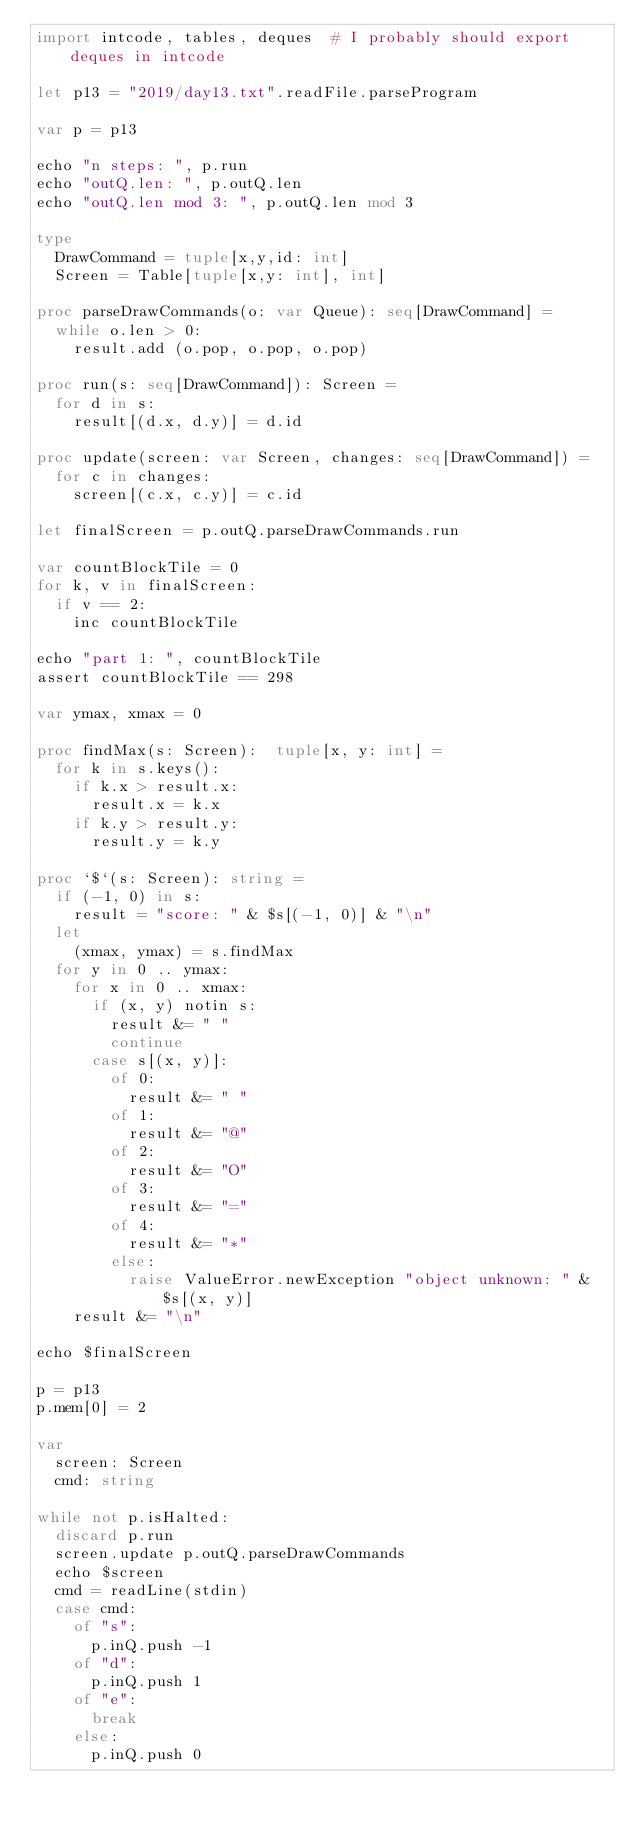<code> <loc_0><loc_0><loc_500><loc_500><_Nim_>import intcode, tables, deques  # I probably should export deques in intcode

let p13 = "2019/day13.txt".readFile.parseProgram

var p = p13

echo "n steps: ", p.run
echo "outQ.len: ", p.outQ.len
echo "outQ.len mod 3: ", p.outQ.len mod 3

type
  DrawCommand = tuple[x,y,id: int]
  Screen = Table[tuple[x,y: int], int]

proc parseDrawCommands(o: var Queue): seq[DrawCommand] =  
  while o.len > 0:
    result.add (o.pop, o.pop, o.pop)

proc run(s: seq[DrawCommand]): Screen =
  for d in s:
    result[(d.x, d.y)] = d.id

proc update(screen: var Screen, changes: seq[DrawCommand]) =
  for c in changes:
    screen[(c.x, c.y)] = c.id

let finalScreen = p.outQ.parseDrawCommands.run

var countBlockTile = 0
for k, v in finalScreen:
  if v == 2:
    inc countBlockTile

echo "part 1: ", countBlockTile
assert countBlockTile == 298

var ymax, xmax = 0

proc findMax(s: Screen):  tuple[x, y: int] =
  for k in s.keys():
    if k.x > result.x:
      result.x = k.x
    if k.y > result.y:
      result.y = k.y

proc `$`(s: Screen): string =
  if (-1, 0) in s:
    result = "score: " & $s[(-1, 0)] & "\n"
  let
    (xmax, ymax) = s.findMax
  for y in 0 .. ymax:
    for x in 0 .. xmax:
      if (x, y) notin s:
        result &= " "
        continue
      case s[(x, y)]:
        of 0:
          result &= " "
        of 1:
          result &= "@"
        of 2:
          result &= "O"
        of 3:
          result &= "="
        of 4:
          result &= "*"
        else:
          raise ValueError.newException "object unknown: " & $s[(x, y)]
    result &= "\n"  

echo $finalScreen

p = p13
p.mem[0] = 2

var
  screen: Screen
  cmd: string

while not p.isHalted:
  discard p.run
  screen.update p.outQ.parseDrawCommands
  echo $screen
  cmd = readLine(stdin)
  case cmd:
    of "s":
      p.inQ.push -1
    of "d":
      p.inQ.push 1
    of "e":
      break
    else:
      p.inQ.push 0

</code> 